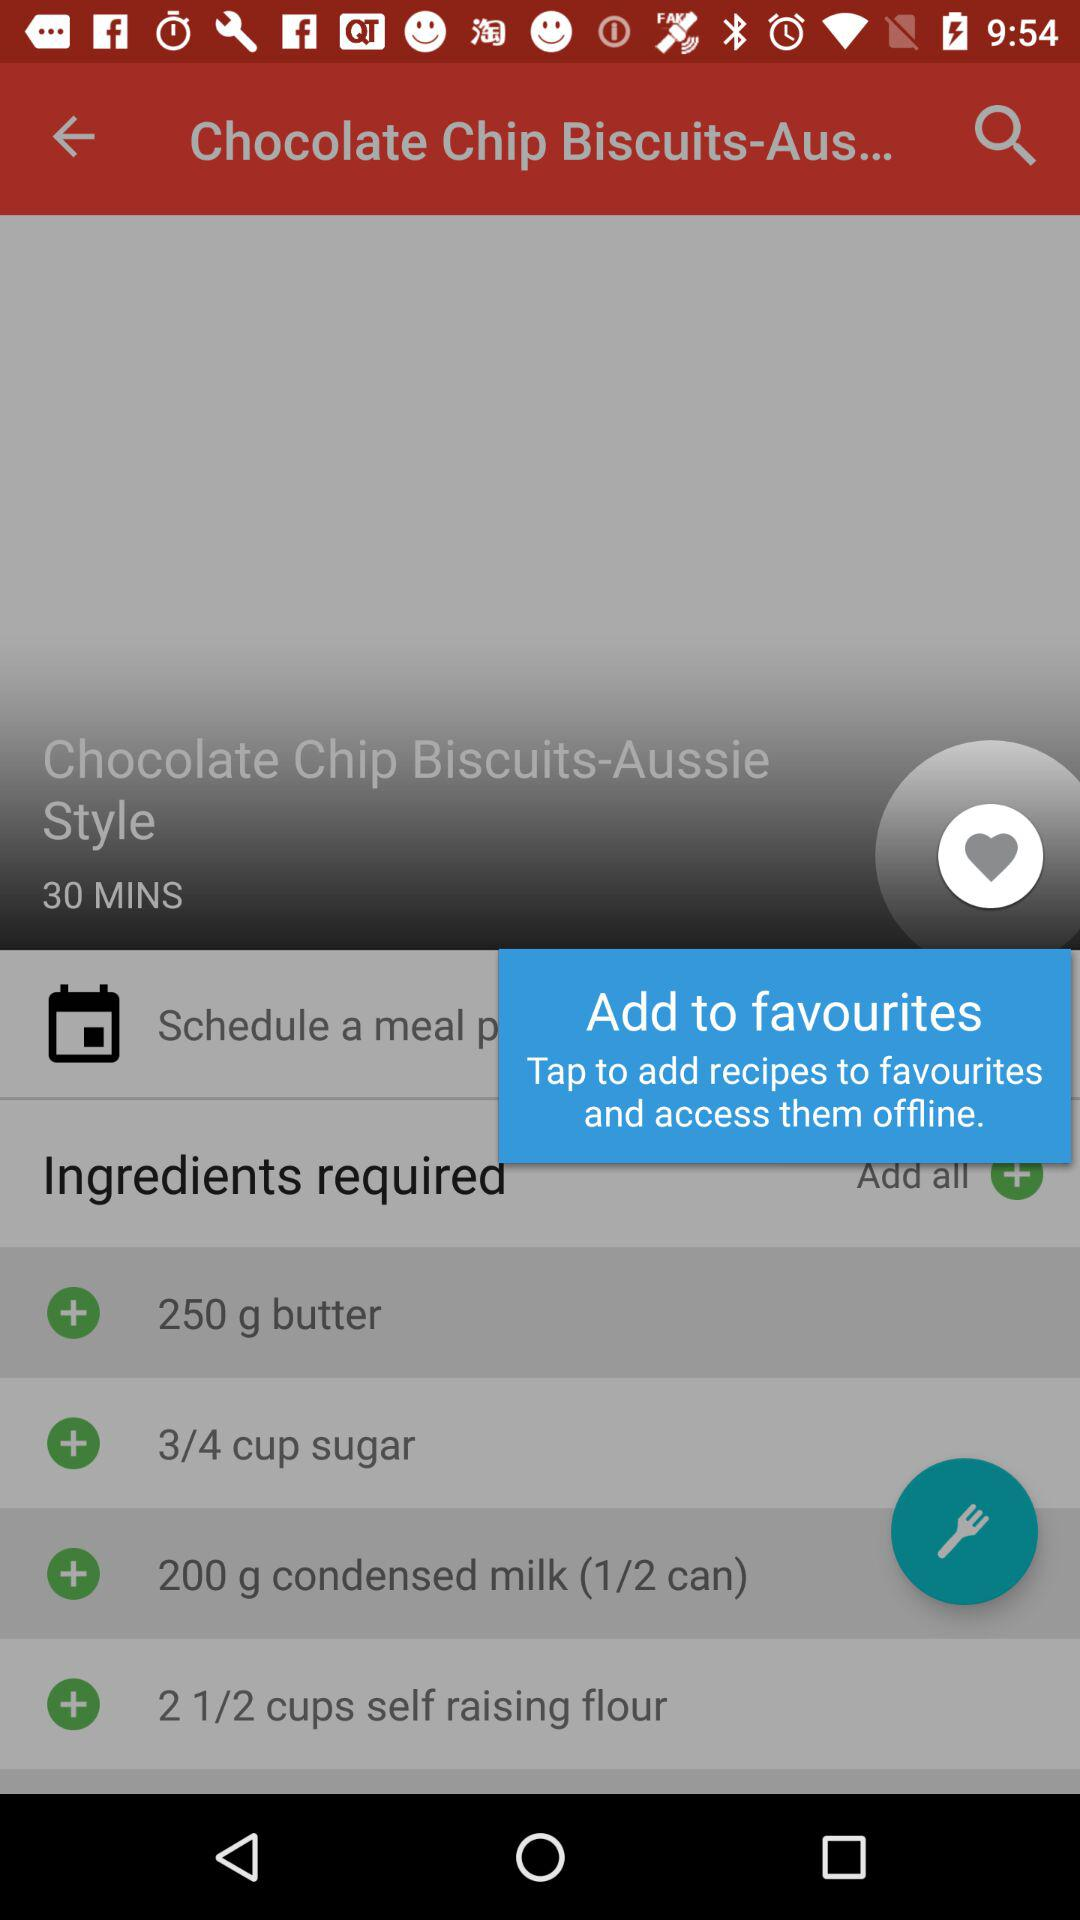How much butter is required in the dish? The required amount of butter is 250 grams. 